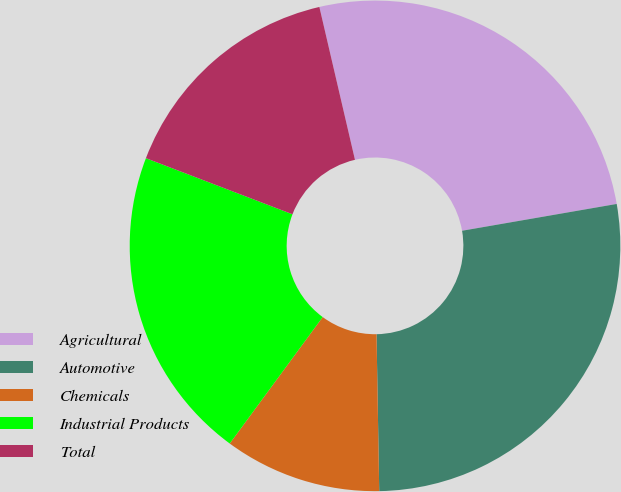Convert chart to OTSL. <chart><loc_0><loc_0><loc_500><loc_500><pie_chart><fcel>Agricultural<fcel>Automotive<fcel>Chemicals<fcel>Industrial Products<fcel>Total<nl><fcel>25.91%<fcel>27.46%<fcel>10.36%<fcel>20.73%<fcel>15.54%<nl></chart> 